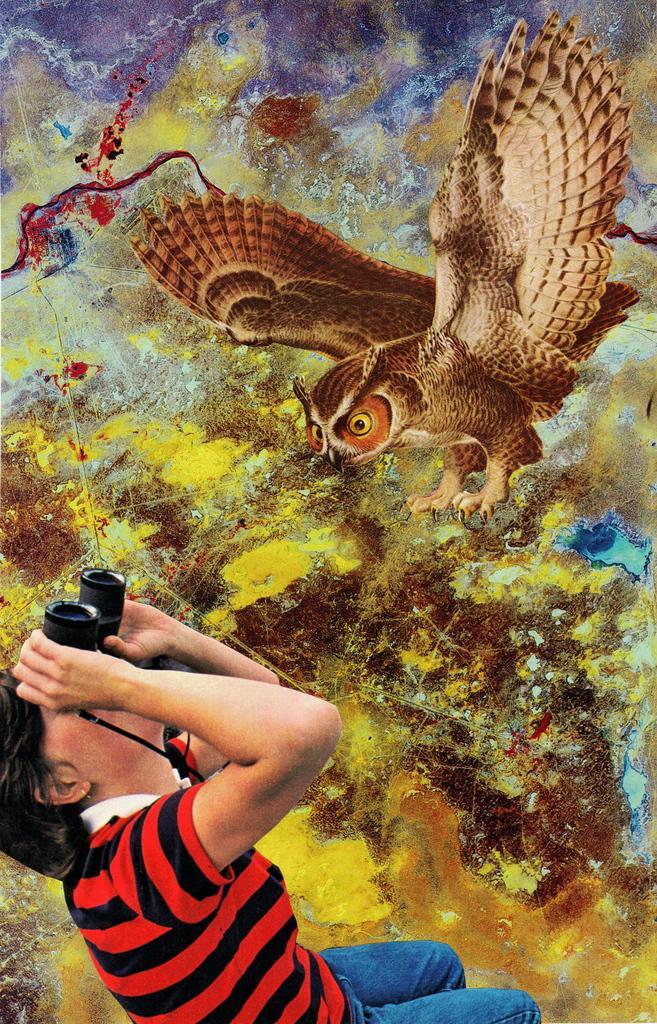Please provide a concise description of this image. In the image we can see there is a man standing and holding binoculars in his hands. There is a painting of an owl on the wall. 